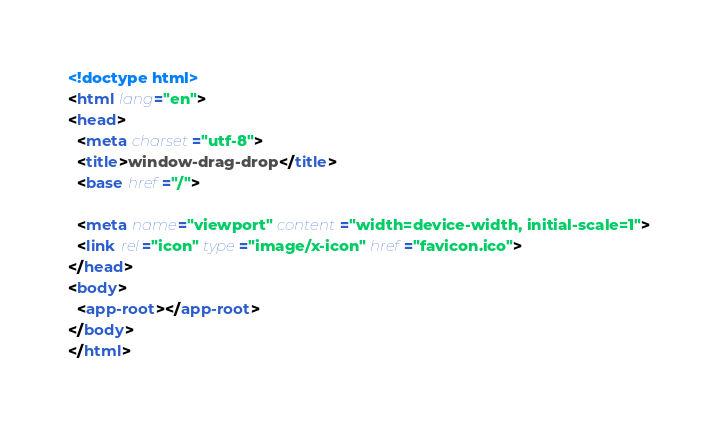Convert code to text. <code><loc_0><loc_0><loc_500><loc_500><_HTML_><!doctype html>
<html lang="en">
<head>
  <meta charset="utf-8">
  <title>window-drag-drop</title>
  <base href="/">

  <meta name="viewport" content="width=device-width, initial-scale=1">
  <link rel="icon" type="image/x-icon" href="favicon.ico">
</head>
<body>
  <app-root></app-root>
</body>
</html>
</code> 